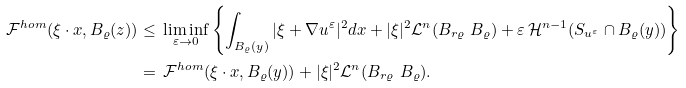Convert formula to latex. <formula><loc_0><loc_0><loc_500><loc_500>\mathcal { F } ^ { h o m } ( \xi \cdot x , B _ { \varrho } ( z ) ) & \leq \, \liminf _ { \varepsilon \rightarrow 0 } \left \{ \int _ { B _ { \varrho } ( y ) } | \xi + \nabla u ^ { \varepsilon } | ^ { 2 } d x + | \xi | ^ { 2 } \mathcal { L } ^ { n } ( B _ { r \varrho } \ B _ { \varrho } ) + \varepsilon \, \mathcal { H } ^ { n - 1 } ( S _ { u ^ { \varepsilon } } \cap B _ { \varrho } ( y ) ) \right \} \\ & = \, \mathcal { F } ^ { h o m } ( \xi \cdot x , B _ { \varrho } ( y ) ) + | \xi | ^ { 2 } \mathcal { L } ^ { n } ( B _ { r \varrho } \ B _ { \varrho } ) .</formula> 